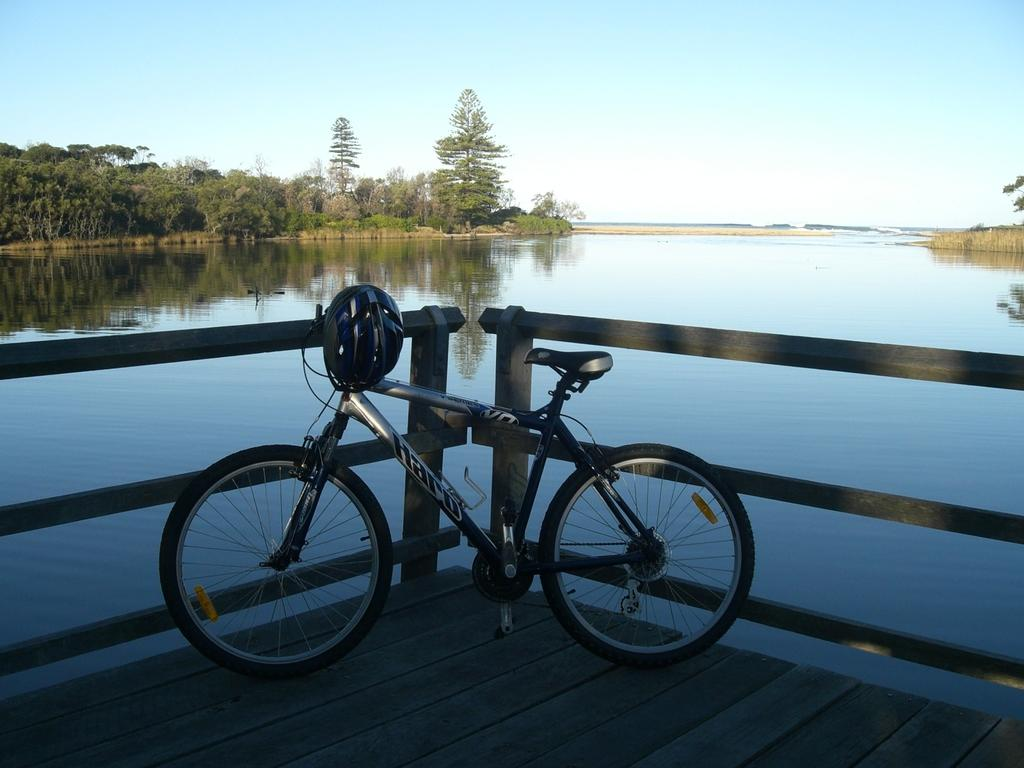What is the main object in the image? There is a bicycle in the image. What safety equipment is present in the image? There is a helmet in the image. What natural element can be seen in the image? There is water visible in the image. What type of vegetation is present in the image? There are trees in the image. What is visible in the background of the image? The sky is visible in the background of the image. Where is the garden located in the image? There is no garden present in the image. How many chairs can be seen in the image? There are no chairs present in the image. 